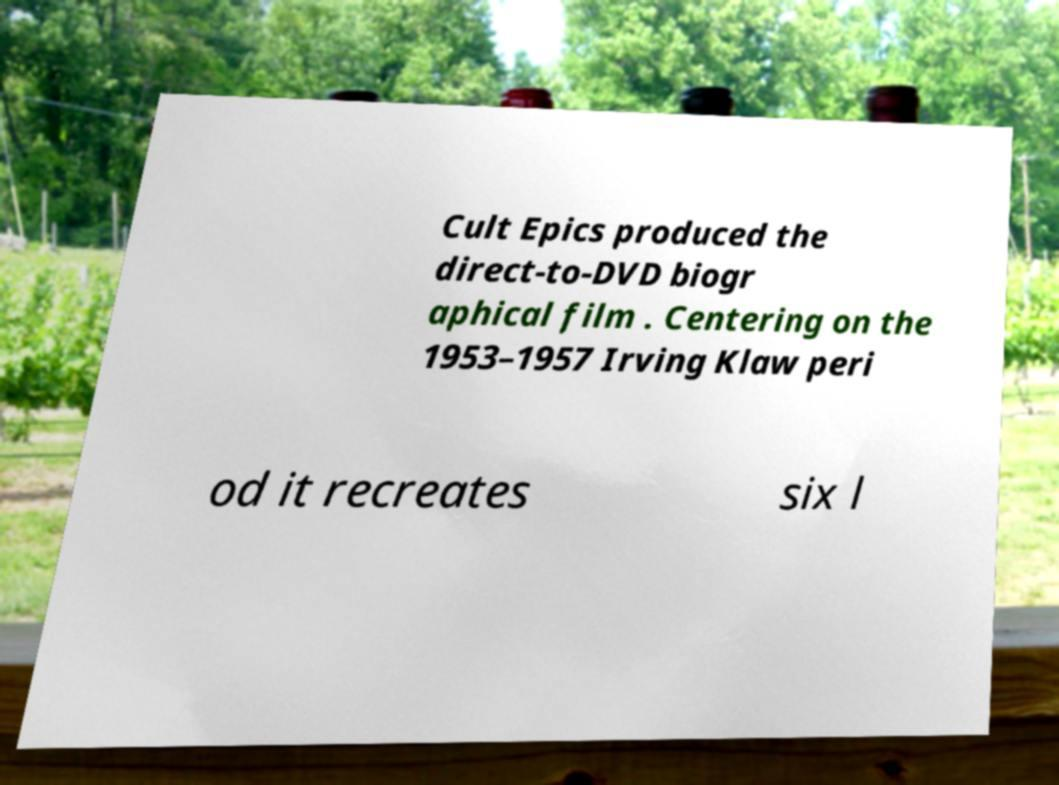Can you read and provide the text displayed in the image?This photo seems to have some interesting text. Can you extract and type it out for me? Cult Epics produced the direct-to-DVD biogr aphical film . Centering on the 1953–1957 Irving Klaw peri od it recreates six l 